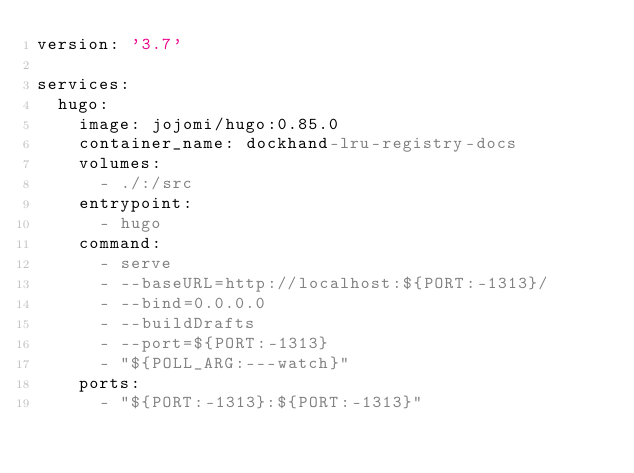Convert code to text. <code><loc_0><loc_0><loc_500><loc_500><_YAML_>version: '3.7'

services:
  hugo:
    image: jojomi/hugo:0.85.0
    container_name: dockhand-lru-registry-docs
    volumes:
      - ./:/src
    entrypoint:
      - hugo
    command:
      - serve
      - --baseURL=http://localhost:${PORT:-1313}/
      - --bind=0.0.0.0
      - --buildDrafts
      - --port=${PORT:-1313}
      - "${POLL_ARG:---watch}"
    ports:
      - "${PORT:-1313}:${PORT:-1313}"
</code> 